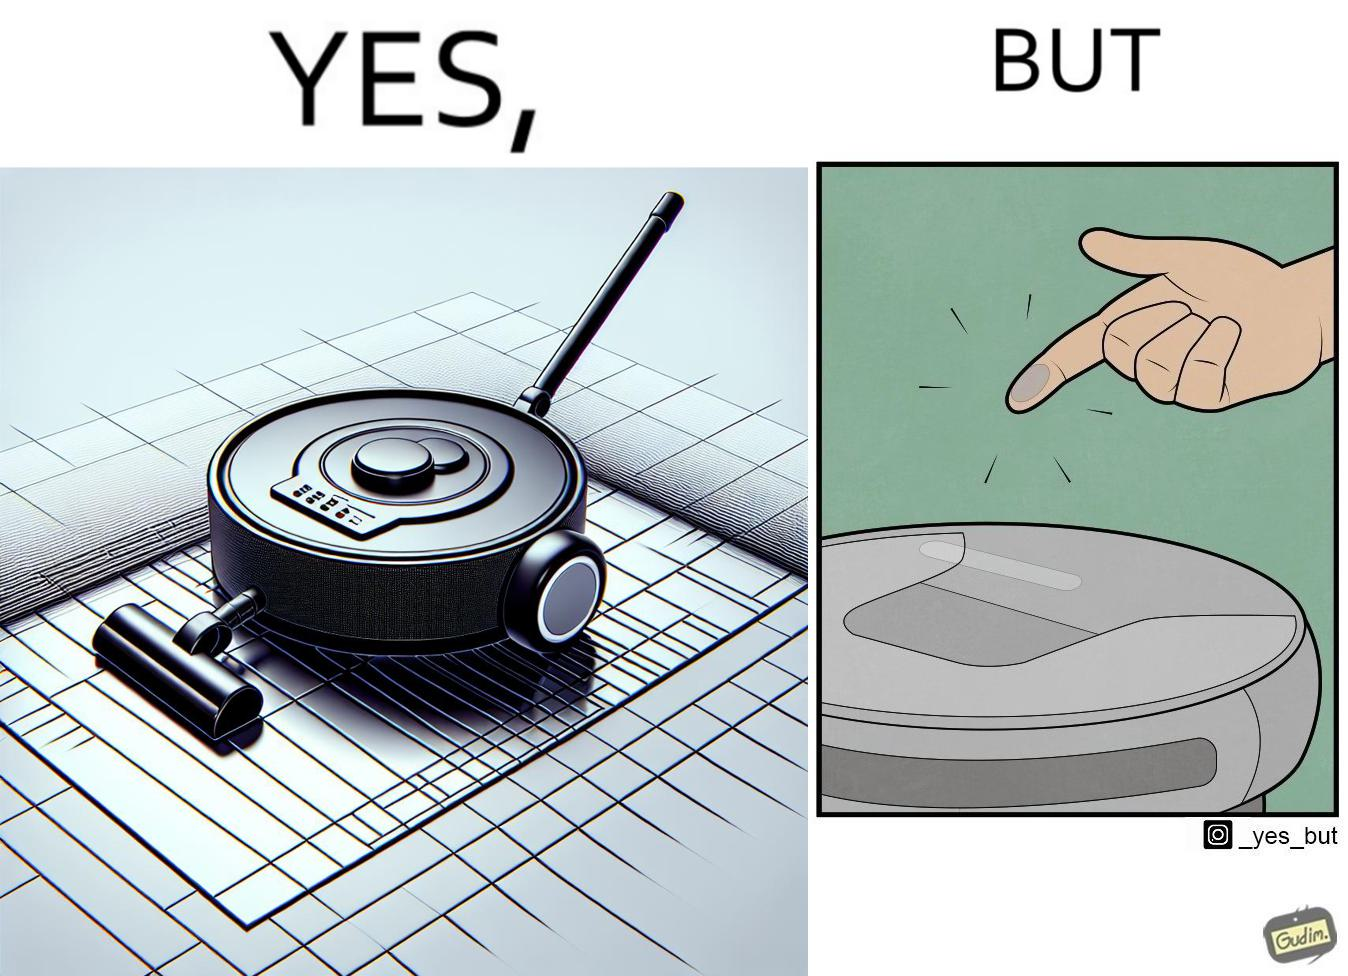Explain why this image is satirical. This is funny, because the machine while doing its job cleans everything but ends up being dirty itself. 